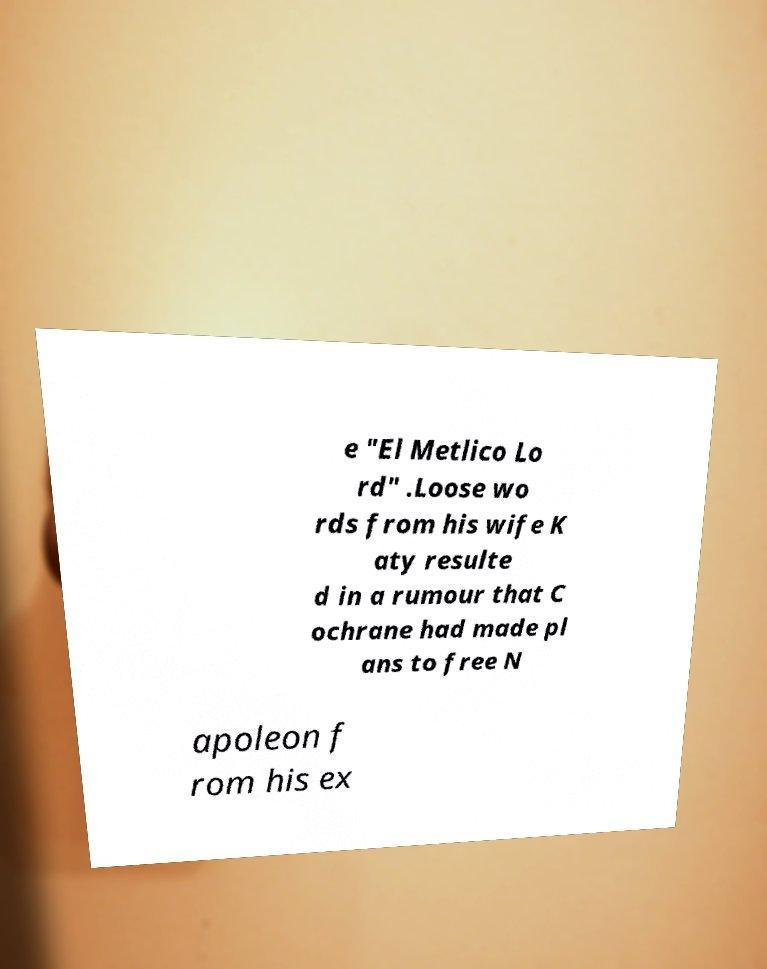Could you assist in decoding the text presented in this image and type it out clearly? e "El Metlico Lo rd" .Loose wo rds from his wife K aty resulte d in a rumour that C ochrane had made pl ans to free N apoleon f rom his ex 